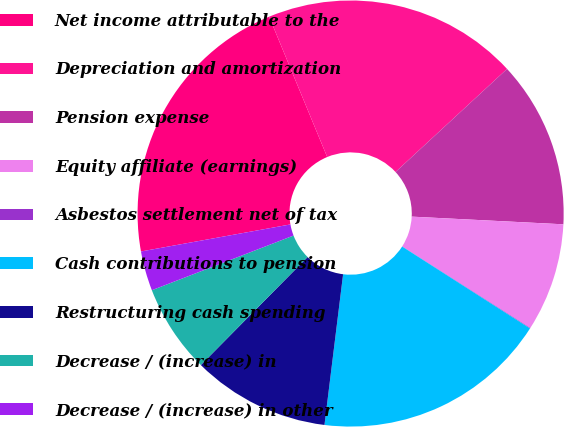<chart> <loc_0><loc_0><loc_500><loc_500><pie_chart><fcel>Net income attributable to the<fcel>Depreciation and amortization<fcel>Pension expense<fcel>Equity affiliate (earnings)<fcel>Asbestos settlement net of tax<fcel>Cash contributions to pension<fcel>Restructuring cash spending<fcel>Decrease / (increase) in<fcel>Decrease / (increase) in other<nl><fcel>21.6%<fcel>19.37%<fcel>12.68%<fcel>8.22%<fcel>0.04%<fcel>17.89%<fcel>10.45%<fcel>6.73%<fcel>3.01%<nl></chart> 